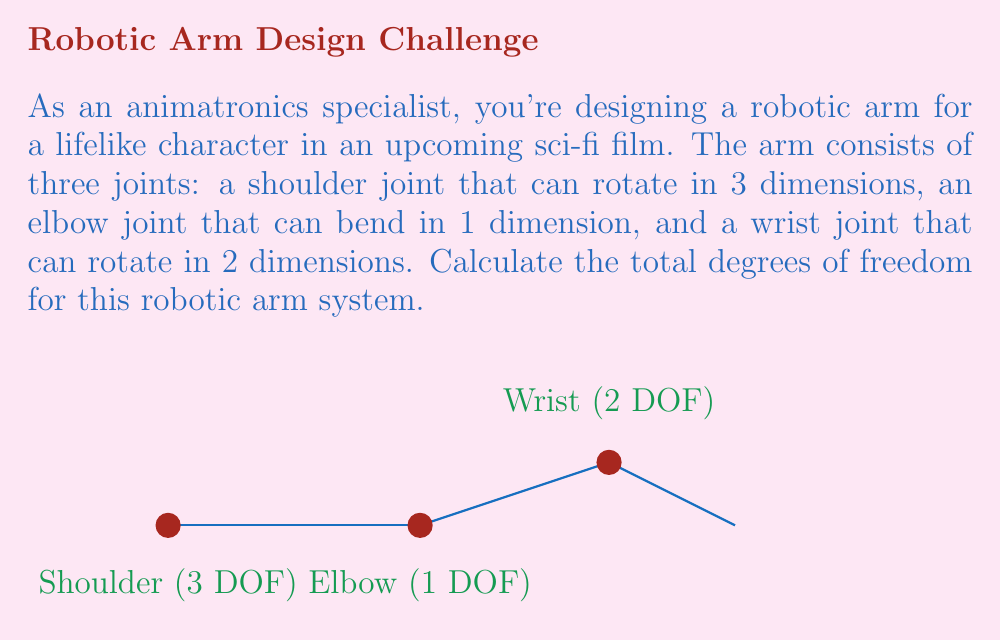Provide a solution to this math problem. To calculate the total degrees of freedom (DOF) in a robotic joint system, we need to sum up the DOF of each individual joint. Let's break it down step-by-step:

1. Shoulder joint:
   The shoulder joint can rotate in 3 dimensions, which means it has 3 DOF.
   $$DOF_{shoulder} = 3$$

2. Elbow joint:
   The elbow joint can bend in 1 dimension, so it has 1 DOF.
   $$DOF_{elbow} = 1$$

3. Wrist joint:
   The wrist joint can rotate in 2 dimensions, giving it 2 DOF.
   $$DOF_{wrist} = 2$$

4. Total DOF:
   To find the total DOF, we sum up the DOF of all joints:
   $$DOF_{total} = DOF_{shoulder} + DOF_{elbow} + DOF_{wrist}$$
   $$DOF_{total} = 3 + 1 + 2 = 6$$

Therefore, the total degrees of freedom for this robotic arm system is 6.
Answer: 6 DOF 